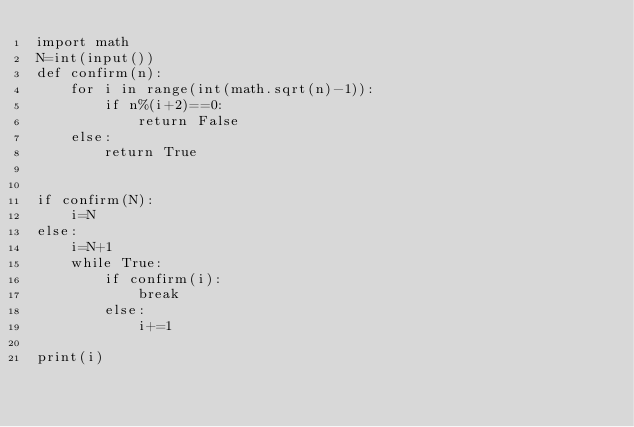<code> <loc_0><loc_0><loc_500><loc_500><_Python_>import math
N=int(input())
def confirm(n):
    for i in range(int(math.sqrt(n)-1)):
        if n%(i+2)==0:
            return False
    else:
        return True


if confirm(N):
    i=N
else:
    i=N+1
    while True:
        if confirm(i):
            break
        else:
            i+=1

print(i)
</code> 